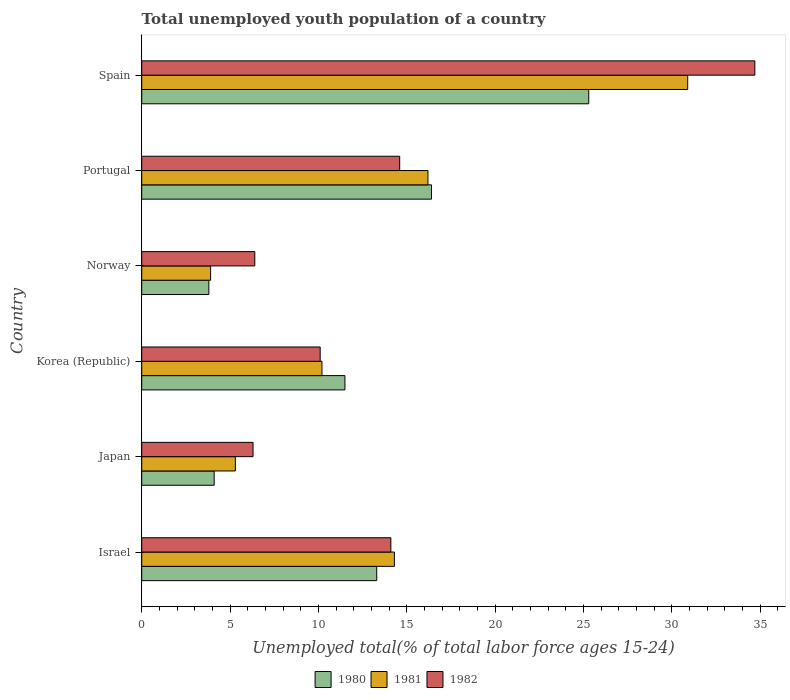How many different coloured bars are there?
Offer a very short reply. 3. What is the label of the 5th group of bars from the top?
Ensure brevity in your answer.  Japan. In how many cases, is the number of bars for a given country not equal to the number of legend labels?
Ensure brevity in your answer.  0. What is the percentage of total unemployed youth population of a country in 1981 in Korea (Republic)?
Keep it short and to the point. 10.2. Across all countries, what is the maximum percentage of total unemployed youth population of a country in 1981?
Your answer should be compact. 30.9. Across all countries, what is the minimum percentage of total unemployed youth population of a country in 1981?
Make the answer very short. 3.9. In which country was the percentage of total unemployed youth population of a country in 1982 maximum?
Provide a short and direct response. Spain. What is the total percentage of total unemployed youth population of a country in 1981 in the graph?
Offer a very short reply. 80.8. What is the difference between the percentage of total unemployed youth population of a country in 1982 in Norway and that in Portugal?
Keep it short and to the point. -8.2. What is the difference between the percentage of total unemployed youth population of a country in 1981 in Israel and the percentage of total unemployed youth population of a country in 1980 in Japan?
Provide a short and direct response. 10.2. What is the average percentage of total unemployed youth population of a country in 1982 per country?
Your answer should be very brief. 14.37. What is the difference between the percentage of total unemployed youth population of a country in 1982 and percentage of total unemployed youth population of a country in 1981 in Korea (Republic)?
Your answer should be very brief. -0.1. In how many countries, is the percentage of total unemployed youth population of a country in 1982 greater than 33 %?
Your response must be concise. 1. What is the ratio of the percentage of total unemployed youth population of a country in 1980 in Israel to that in Japan?
Make the answer very short. 3.24. What is the difference between the highest and the second highest percentage of total unemployed youth population of a country in 1981?
Keep it short and to the point. 14.7. What is the difference between the highest and the lowest percentage of total unemployed youth population of a country in 1980?
Provide a short and direct response. 21.5. In how many countries, is the percentage of total unemployed youth population of a country in 1980 greater than the average percentage of total unemployed youth population of a country in 1980 taken over all countries?
Ensure brevity in your answer.  3. Is the sum of the percentage of total unemployed youth population of a country in 1982 in Portugal and Spain greater than the maximum percentage of total unemployed youth population of a country in 1980 across all countries?
Your answer should be very brief. Yes. What does the 1st bar from the top in Korea (Republic) represents?
Provide a short and direct response. 1982. What does the 3rd bar from the bottom in Japan represents?
Ensure brevity in your answer.  1982. Is it the case that in every country, the sum of the percentage of total unemployed youth population of a country in 1981 and percentage of total unemployed youth population of a country in 1982 is greater than the percentage of total unemployed youth population of a country in 1980?
Offer a terse response. Yes. How many bars are there?
Your answer should be very brief. 18. Does the graph contain any zero values?
Make the answer very short. No. How are the legend labels stacked?
Your answer should be compact. Horizontal. What is the title of the graph?
Give a very brief answer. Total unemployed youth population of a country. What is the label or title of the X-axis?
Keep it short and to the point. Unemployed total(% of total labor force ages 15-24). What is the label or title of the Y-axis?
Keep it short and to the point. Country. What is the Unemployed total(% of total labor force ages 15-24) in 1980 in Israel?
Your answer should be compact. 13.3. What is the Unemployed total(% of total labor force ages 15-24) in 1981 in Israel?
Keep it short and to the point. 14.3. What is the Unemployed total(% of total labor force ages 15-24) of 1982 in Israel?
Ensure brevity in your answer.  14.1. What is the Unemployed total(% of total labor force ages 15-24) in 1980 in Japan?
Ensure brevity in your answer.  4.1. What is the Unemployed total(% of total labor force ages 15-24) of 1981 in Japan?
Give a very brief answer. 5.3. What is the Unemployed total(% of total labor force ages 15-24) of 1982 in Japan?
Your response must be concise. 6.3. What is the Unemployed total(% of total labor force ages 15-24) of 1980 in Korea (Republic)?
Offer a very short reply. 11.5. What is the Unemployed total(% of total labor force ages 15-24) in 1981 in Korea (Republic)?
Offer a terse response. 10.2. What is the Unemployed total(% of total labor force ages 15-24) of 1982 in Korea (Republic)?
Your answer should be very brief. 10.1. What is the Unemployed total(% of total labor force ages 15-24) in 1980 in Norway?
Provide a succinct answer. 3.8. What is the Unemployed total(% of total labor force ages 15-24) of 1981 in Norway?
Offer a very short reply. 3.9. What is the Unemployed total(% of total labor force ages 15-24) in 1982 in Norway?
Make the answer very short. 6.4. What is the Unemployed total(% of total labor force ages 15-24) of 1980 in Portugal?
Keep it short and to the point. 16.4. What is the Unemployed total(% of total labor force ages 15-24) in 1981 in Portugal?
Give a very brief answer. 16.2. What is the Unemployed total(% of total labor force ages 15-24) in 1982 in Portugal?
Offer a terse response. 14.6. What is the Unemployed total(% of total labor force ages 15-24) in 1980 in Spain?
Provide a short and direct response. 25.3. What is the Unemployed total(% of total labor force ages 15-24) of 1981 in Spain?
Ensure brevity in your answer.  30.9. What is the Unemployed total(% of total labor force ages 15-24) in 1982 in Spain?
Keep it short and to the point. 34.7. Across all countries, what is the maximum Unemployed total(% of total labor force ages 15-24) in 1980?
Give a very brief answer. 25.3. Across all countries, what is the maximum Unemployed total(% of total labor force ages 15-24) of 1981?
Make the answer very short. 30.9. Across all countries, what is the maximum Unemployed total(% of total labor force ages 15-24) of 1982?
Give a very brief answer. 34.7. Across all countries, what is the minimum Unemployed total(% of total labor force ages 15-24) of 1980?
Offer a very short reply. 3.8. Across all countries, what is the minimum Unemployed total(% of total labor force ages 15-24) in 1981?
Make the answer very short. 3.9. Across all countries, what is the minimum Unemployed total(% of total labor force ages 15-24) of 1982?
Your answer should be very brief. 6.3. What is the total Unemployed total(% of total labor force ages 15-24) in 1980 in the graph?
Provide a short and direct response. 74.4. What is the total Unemployed total(% of total labor force ages 15-24) in 1981 in the graph?
Provide a short and direct response. 80.8. What is the total Unemployed total(% of total labor force ages 15-24) of 1982 in the graph?
Your response must be concise. 86.2. What is the difference between the Unemployed total(% of total labor force ages 15-24) in 1981 in Israel and that in Japan?
Your answer should be very brief. 9. What is the difference between the Unemployed total(% of total labor force ages 15-24) in 1981 in Israel and that in Korea (Republic)?
Ensure brevity in your answer.  4.1. What is the difference between the Unemployed total(% of total labor force ages 15-24) in 1982 in Israel and that in Korea (Republic)?
Provide a short and direct response. 4. What is the difference between the Unemployed total(% of total labor force ages 15-24) in 1981 in Israel and that in Norway?
Ensure brevity in your answer.  10.4. What is the difference between the Unemployed total(% of total labor force ages 15-24) of 1982 in Israel and that in Norway?
Provide a short and direct response. 7.7. What is the difference between the Unemployed total(% of total labor force ages 15-24) in 1982 in Israel and that in Portugal?
Give a very brief answer. -0.5. What is the difference between the Unemployed total(% of total labor force ages 15-24) of 1981 in Israel and that in Spain?
Offer a terse response. -16.6. What is the difference between the Unemployed total(% of total labor force ages 15-24) of 1982 in Israel and that in Spain?
Offer a very short reply. -20.6. What is the difference between the Unemployed total(% of total labor force ages 15-24) of 1981 in Japan and that in Korea (Republic)?
Offer a very short reply. -4.9. What is the difference between the Unemployed total(% of total labor force ages 15-24) in 1982 in Japan and that in Korea (Republic)?
Make the answer very short. -3.8. What is the difference between the Unemployed total(% of total labor force ages 15-24) of 1982 in Japan and that in Norway?
Offer a terse response. -0.1. What is the difference between the Unemployed total(% of total labor force ages 15-24) of 1980 in Japan and that in Portugal?
Provide a short and direct response. -12.3. What is the difference between the Unemployed total(% of total labor force ages 15-24) in 1982 in Japan and that in Portugal?
Make the answer very short. -8.3. What is the difference between the Unemployed total(% of total labor force ages 15-24) in 1980 in Japan and that in Spain?
Make the answer very short. -21.2. What is the difference between the Unemployed total(% of total labor force ages 15-24) of 1981 in Japan and that in Spain?
Ensure brevity in your answer.  -25.6. What is the difference between the Unemployed total(% of total labor force ages 15-24) in 1982 in Japan and that in Spain?
Give a very brief answer. -28.4. What is the difference between the Unemployed total(% of total labor force ages 15-24) of 1980 in Korea (Republic) and that in Norway?
Your answer should be very brief. 7.7. What is the difference between the Unemployed total(% of total labor force ages 15-24) of 1981 in Korea (Republic) and that in Norway?
Make the answer very short. 6.3. What is the difference between the Unemployed total(% of total labor force ages 15-24) in 1982 in Korea (Republic) and that in Norway?
Make the answer very short. 3.7. What is the difference between the Unemployed total(% of total labor force ages 15-24) of 1980 in Korea (Republic) and that in Portugal?
Your answer should be very brief. -4.9. What is the difference between the Unemployed total(% of total labor force ages 15-24) of 1982 in Korea (Republic) and that in Portugal?
Your answer should be very brief. -4.5. What is the difference between the Unemployed total(% of total labor force ages 15-24) of 1981 in Korea (Republic) and that in Spain?
Offer a very short reply. -20.7. What is the difference between the Unemployed total(% of total labor force ages 15-24) in 1982 in Korea (Republic) and that in Spain?
Provide a succinct answer. -24.6. What is the difference between the Unemployed total(% of total labor force ages 15-24) in 1980 in Norway and that in Spain?
Your answer should be very brief. -21.5. What is the difference between the Unemployed total(% of total labor force ages 15-24) in 1981 in Norway and that in Spain?
Your answer should be compact. -27. What is the difference between the Unemployed total(% of total labor force ages 15-24) of 1982 in Norway and that in Spain?
Offer a terse response. -28.3. What is the difference between the Unemployed total(% of total labor force ages 15-24) of 1980 in Portugal and that in Spain?
Your answer should be compact. -8.9. What is the difference between the Unemployed total(% of total labor force ages 15-24) in 1981 in Portugal and that in Spain?
Offer a terse response. -14.7. What is the difference between the Unemployed total(% of total labor force ages 15-24) in 1982 in Portugal and that in Spain?
Offer a terse response. -20.1. What is the difference between the Unemployed total(% of total labor force ages 15-24) of 1980 in Israel and the Unemployed total(% of total labor force ages 15-24) of 1982 in Japan?
Give a very brief answer. 7. What is the difference between the Unemployed total(% of total labor force ages 15-24) in 1980 in Israel and the Unemployed total(% of total labor force ages 15-24) in 1981 in Korea (Republic)?
Keep it short and to the point. 3.1. What is the difference between the Unemployed total(% of total labor force ages 15-24) in 1980 in Israel and the Unemployed total(% of total labor force ages 15-24) in 1982 in Korea (Republic)?
Make the answer very short. 3.2. What is the difference between the Unemployed total(% of total labor force ages 15-24) of 1980 in Israel and the Unemployed total(% of total labor force ages 15-24) of 1981 in Norway?
Your answer should be compact. 9.4. What is the difference between the Unemployed total(% of total labor force ages 15-24) in 1980 in Israel and the Unemployed total(% of total labor force ages 15-24) in 1982 in Norway?
Keep it short and to the point. 6.9. What is the difference between the Unemployed total(% of total labor force ages 15-24) of 1981 in Israel and the Unemployed total(% of total labor force ages 15-24) of 1982 in Norway?
Provide a short and direct response. 7.9. What is the difference between the Unemployed total(% of total labor force ages 15-24) in 1980 in Israel and the Unemployed total(% of total labor force ages 15-24) in 1981 in Spain?
Offer a terse response. -17.6. What is the difference between the Unemployed total(% of total labor force ages 15-24) of 1980 in Israel and the Unemployed total(% of total labor force ages 15-24) of 1982 in Spain?
Offer a terse response. -21.4. What is the difference between the Unemployed total(% of total labor force ages 15-24) in 1981 in Israel and the Unemployed total(% of total labor force ages 15-24) in 1982 in Spain?
Keep it short and to the point. -20.4. What is the difference between the Unemployed total(% of total labor force ages 15-24) in 1980 in Japan and the Unemployed total(% of total labor force ages 15-24) in 1981 in Korea (Republic)?
Offer a very short reply. -6.1. What is the difference between the Unemployed total(% of total labor force ages 15-24) of 1980 in Japan and the Unemployed total(% of total labor force ages 15-24) of 1981 in Norway?
Your answer should be very brief. 0.2. What is the difference between the Unemployed total(% of total labor force ages 15-24) in 1980 in Japan and the Unemployed total(% of total labor force ages 15-24) in 1981 in Portugal?
Provide a succinct answer. -12.1. What is the difference between the Unemployed total(% of total labor force ages 15-24) of 1981 in Japan and the Unemployed total(% of total labor force ages 15-24) of 1982 in Portugal?
Keep it short and to the point. -9.3. What is the difference between the Unemployed total(% of total labor force ages 15-24) in 1980 in Japan and the Unemployed total(% of total labor force ages 15-24) in 1981 in Spain?
Your answer should be compact. -26.8. What is the difference between the Unemployed total(% of total labor force ages 15-24) of 1980 in Japan and the Unemployed total(% of total labor force ages 15-24) of 1982 in Spain?
Give a very brief answer. -30.6. What is the difference between the Unemployed total(% of total labor force ages 15-24) of 1981 in Japan and the Unemployed total(% of total labor force ages 15-24) of 1982 in Spain?
Offer a terse response. -29.4. What is the difference between the Unemployed total(% of total labor force ages 15-24) in 1980 in Korea (Republic) and the Unemployed total(% of total labor force ages 15-24) in 1982 in Norway?
Your answer should be very brief. 5.1. What is the difference between the Unemployed total(% of total labor force ages 15-24) in 1980 in Korea (Republic) and the Unemployed total(% of total labor force ages 15-24) in 1981 in Portugal?
Make the answer very short. -4.7. What is the difference between the Unemployed total(% of total labor force ages 15-24) in 1980 in Korea (Republic) and the Unemployed total(% of total labor force ages 15-24) in 1982 in Portugal?
Give a very brief answer. -3.1. What is the difference between the Unemployed total(% of total labor force ages 15-24) in 1980 in Korea (Republic) and the Unemployed total(% of total labor force ages 15-24) in 1981 in Spain?
Offer a terse response. -19.4. What is the difference between the Unemployed total(% of total labor force ages 15-24) in 1980 in Korea (Republic) and the Unemployed total(% of total labor force ages 15-24) in 1982 in Spain?
Ensure brevity in your answer.  -23.2. What is the difference between the Unemployed total(% of total labor force ages 15-24) in 1981 in Korea (Republic) and the Unemployed total(% of total labor force ages 15-24) in 1982 in Spain?
Provide a succinct answer. -24.5. What is the difference between the Unemployed total(% of total labor force ages 15-24) of 1980 in Norway and the Unemployed total(% of total labor force ages 15-24) of 1981 in Portugal?
Your response must be concise. -12.4. What is the difference between the Unemployed total(% of total labor force ages 15-24) of 1980 in Norway and the Unemployed total(% of total labor force ages 15-24) of 1982 in Portugal?
Offer a very short reply. -10.8. What is the difference between the Unemployed total(% of total labor force ages 15-24) in 1980 in Norway and the Unemployed total(% of total labor force ages 15-24) in 1981 in Spain?
Your response must be concise. -27.1. What is the difference between the Unemployed total(% of total labor force ages 15-24) of 1980 in Norway and the Unemployed total(% of total labor force ages 15-24) of 1982 in Spain?
Provide a short and direct response. -30.9. What is the difference between the Unemployed total(% of total labor force ages 15-24) in 1981 in Norway and the Unemployed total(% of total labor force ages 15-24) in 1982 in Spain?
Offer a very short reply. -30.8. What is the difference between the Unemployed total(% of total labor force ages 15-24) in 1980 in Portugal and the Unemployed total(% of total labor force ages 15-24) in 1981 in Spain?
Your answer should be compact. -14.5. What is the difference between the Unemployed total(% of total labor force ages 15-24) of 1980 in Portugal and the Unemployed total(% of total labor force ages 15-24) of 1982 in Spain?
Ensure brevity in your answer.  -18.3. What is the difference between the Unemployed total(% of total labor force ages 15-24) of 1981 in Portugal and the Unemployed total(% of total labor force ages 15-24) of 1982 in Spain?
Give a very brief answer. -18.5. What is the average Unemployed total(% of total labor force ages 15-24) of 1980 per country?
Ensure brevity in your answer.  12.4. What is the average Unemployed total(% of total labor force ages 15-24) in 1981 per country?
Offer a terse response. 13.47. What is the average Unemployed total(% of total labor force ages 15-24) of 1982 per country?
Ensure brevity in your answer.  14.37. What is the difference between the Unemployed total(% of total labor force ages 15-24) in 1980 and Unemployed total(% of total labor force ages 15-24) in 1981 in Japan?
Ensure brevity in your answer.  -1.2. What is the difference between the Unemployed total(% of total labor force ages 15-24) of 1980 and Unemployed total(% of total labor force ages 15-24) of 1982 in Korea (Republic)?
Offer a very short reply. 1.4. What is the difference between the Unemployed total(% of total labor force ages 15-24) in 1981 and Unemployed total(% of total labor force ages 15-24) in 1982 in Korea (Republic)?
Give a very brief answer. 0.1. What is the difference between the Unemployed total(% of total labor force ages 15-24) in 1980 and Unemployed total(% of total labor force ages 15-24) in 1982 in Norway?
Provide a short and direct response. -2.6. What is the difference between the Unemployed total(% of total labor force ages 15-24) of 1980 and Unemployed total(% of total labor force ages 15-24) of 1981 in Portugal?
Give a very brief answer. 0.2. What is the difference between the Unemployed total(% of total labor force ages 15-24) in 1980 and Unemployed total(% of total labor force ages 15-24) in 1982 in Portugal?
Provide a short and direct response. 1.8. What is the difference between the Unemployed total(% of total labor force ages 15-24) in 1980 and Unemployed total(% of total labor force ages 15-24) in 1982 in Spain?
Your answer should be compact. -9.4. What is the difference between the Unemployed total(% of total labor force ages 15-24) of 1981 and Unemployed total(% of total labor force ages 15-24) of 1982 in Spain?
Your answer should be very brief. -3.8. What is the ratio of the Unemployed total(% of total labor force ages 15-24) of 1980 in Israel to that in Japan?
Your answer should be compact. 3.24. What is the ratio of the Unemployed total(% of total labor force ages 15-24) in 1981 in Israel to that in Japan?
Give a very brief answer. 2.7. What is the ratio of the Unemployed total(% of total labor force ages 15-24) in 1982 in Israel to that in Japan?
Make the answer very short. 2.24. What is the ratio of the Unemployed total(% of total labor force ages 15-24) in 1980 in Israel to that in Korea (Republic)?
Provide a short and direct response. 1.16. What is the ratio of the Unemployed total(% of total labor force ages 15-24) of 1981 in Israel to that in Korea (Republic)?
Provide a succinct answer. 1.4. What is the ratio of the Unemployed total(% of total labor force ages 15-24) of 1982 in Israel to that in Korea (Republic)?
Keep it short and to the point. 1.4. What is the ratio of the Unemployed total(% of total labor force ages 15-24) of 1981 in Israel to that in Norway?
Make the answer very short. 3.67. What is the ratio of the Unemployed total(% of total labor force ages 15-24) in 1982 in Israel to that in Norway?
Keep it short and to the point. 2.2. What is the ratio of the Unemployed total(% of total labor force ages 15-24) of 1980 in Israel to that in Portugal?
Your answer should be compact. 0.81. What is the ratio of the Unemployed total(% of total labor force ages 15-24) in 1981 in Israel to that in Portugal?
Provide a short and direct response. 0.88. What is the ratio of the Unemployed total(% of total labor force ages 15-24) of 1982 in Israel to that in Portugal?
Ensure brevity in your answer.  0.97. What is the ratio of the Unemployed total(% of total labor force ages 15-24) in 1980 in Israel to that in Spain?
Make the answer very short. 0.53. What is the ratio of the Unemployed total(% of total labor force ages 15-24) of 1981 in Israel to that in Spain?
Your answer should be compact. 0.46. What is the ratio of the Unemployed total(% of total labor force ages 15-24) of 1982 in Israel to that in Spain?
Make the answer very short. 0.41. What is the ratio of the Unemployed total(% of total labor force ages 15-24) in 1980 in Japan to that in Korea (Republic)?
Provide a succinct answer. 0.36. What is the ratio of the Unemployed total(% of total labor force ages 15-24) in 1981 in Japan to that in Korea (Republic)?
Provide a short and direct response. 0.52. What is the ratio of the Unemployed total(% of total labor force ages 15-24) of 1982 in Japan to that in Korea (Republic)?
Your answer should be very brief. 0.62. What is the ratio of the Unemployed total(% of total labor force ages 15-24) of 1980 in Japan to that in Norway?
Make the answer very short. 1.08. What is the ratio of the Unemployed total(% of total labor force ages 15-24) in 1981 in Japan to that in Norway?
Provide a short and direct response. 1.36. What is the ratio of the Unemployed total(% of total labor force ages 15-24) in 1982 in Japan to that in Norway?
Give a very brief answer. 0.98. What is the ratio of the Unemployed total(% of total labor force ages 15-24) in 1981 in Japan to that in Portugal?
Give a very brief answer. 0.33. What is the ratio of the Unemployed total(% of total labor force ages 15-24) in 1982 in Japan to that in Portugal?
Keep it short and to the point. 0.43. What is the ratio of the Unemployed total(% of total labor force ages 15-24) of 1980 in Japan to that in Spain?
Your answer should be very brief. 0.16. What is the ratio of the Unemployed total(% of total labor force ages 15-24) in 1981 in Japan to that in Spain?
Your answer should be very brief. 0.17. What is the ratio of the Unemployed total(% of total labor force ages 15-24) of 1982 in Japan to that in Spain?
Offer a very short reply. 0.18. What is the ratio of the Unemployed total(% of total labor force ages 15-24) of 1980 in Korea (Republic) to that in Norway?
Keep it short and to the point. 3.03. What is the ratio of the Unemployed total(% of total labor force ages 15-24) in 1981 in Korea (Republic) to that in Norway?
Make the answer very short. 2.62. What is the ratio of the Unemployed total(% of total labor force ages 15-24) of 1982 in Korea (Republic) to that in Norway?
Your response must be concise. 1.58. What is the ratio of the Unemployed total(% of total labor force ages 15-24) of 1980 in Korea (Republic) to that in Portugal?
Ensure brevity in your answer.  0.7. What is the ratio of the Unemployed total(% of total labor force ages 15-24) of 1981 in Korea (Republic) to that in Portugal?
Your answer should be compact. 0.63. What is the ratio of the Unemployed total(% of total labor force ages 15-24) of 1982 in Korea (Republic) to that in Portugal?
Your answer should be very brief. 0.69. What is the ratio of the Unemployed total(% of total labor force ages 15-24) of 1980 in Korea (Republic) to that in Spain?
Make the answer very short. 0.45. What is the ratio of the Unemployed total(% of total labor force ages 15-24) of 1981 in Korea (Republic) to that in Spain?
Provide a short and direct response. 0.33. What is the ratio of the Unemployed total(% of total labor force ages 15-24) in 1982 in Korea (Republic) to that in Spain?
Offer a terse response. 0.29. What is the ratio of the Unemployed total(% of total labor force ages 15-24) of 1980 in Norway to that in Portugal?
Make the answer very short. 0.23. What is the ratio of the Unemployed total(% of total labor force ages 15-24) of 1981 in Norway to that in Portugal?
Make the answer very short. 0.24. What is the ratio of the Unemployed total(% of total labor force ages 15-24) of 1982 in Norway to that in Portugal?
Ensure brevity in your answer.  0.44. What is the ratio of the Unemployed total(% of total labor force ages 15-24) of 1980 in Norway to that in Spain?
Your answer should be compact. 0.15. What is the ratio of the Unemployed total(% of total labor force ages 15-24) of 1981 in Norway to that in Spain?
Offer a terse response. 0.13. What is the ratio of the Unemployed total(% of total labor force ages 15-24) in 1982 in Norway to that in Spain?
Keep it short and to the point. 0.18. What is the ratio of the Unemployed total(% of total labor force ages 15-24) of 1980 in Portugal to that in Spain?
Offer a very short reply. 0.65. What is the ratio of the Unemployed total(% of total labor force ages 15-24) of 1981 in Portugal to that in Spain?
Keep it short and to the point. 0.52. What is the ratio of the Unemployed total(% of total labor force ages 15-24) in 1982 in Portugal to that in Spain?
Offer a terse response. 0.42. What is the difference between the highest and the second highest Unemployed total(% of total labor force ages 15-24) in 1980?
Your answer should be compact. 8.9. What is the difference between the highest and the second highest Unemployed total(% of total labor force ages 15-24) in 1981?
Keep it short and to the point. 14.7. What is the difference between the highest and the second highest Unemployed total(% of total labor force ages 15-24) in 1982?
Give a very brief answer. 20.1. What is the difference between the highest and the lowest Unemployed total(% of total labor force ages 15-24) in 1980?
Make the answer very short. 21.5. What is the difference between the highest and the lowest Unemployed total(% of total labor force ages 15-24) in 1981?
Keep it short and to the point. 27. What is the difference between the highest and the lowest Unemployed total(% of total labor force ages 15-24) of 1982?
Your answer should be very brief. 28.4. 